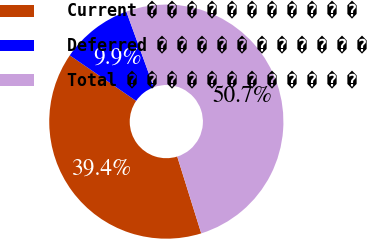Convert chart. <chart><loc_0><loc_0><loc_500><loc_500><pie_chart><fcel>Current � � � � � � � � � � �<fcel>Deferred � � � � � � � � � � �<fcel>Total � � � � � � � � � � � �<nl><fcel>39.39%<fcel>9.88%<fcel>50.73%<nl></chart> 